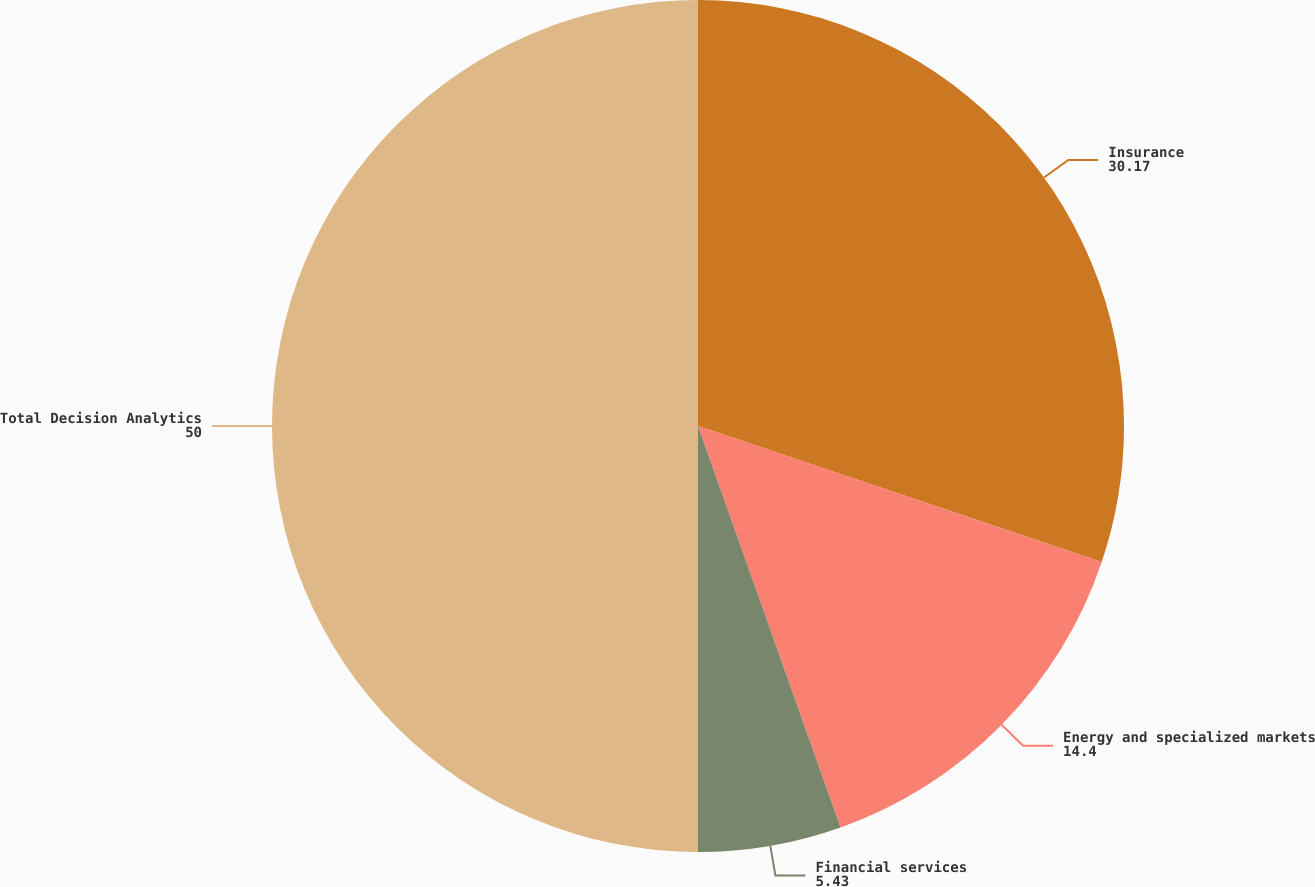<chart> <loc_0><loc_0><loc_500><loc_500><pie_chart><fcel>Insurance<fcel>Energy and specialized markets<fcel>Financial services<fcel>Total Decision Analytics<nl><fcel>30.17%<fcel>14.4%<fcel>5.43%<fcel>50.0%<nl></chart> 